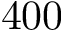<formula> <loc_0><loc_0><loc_500><loc_500>4 0 0</formula> 